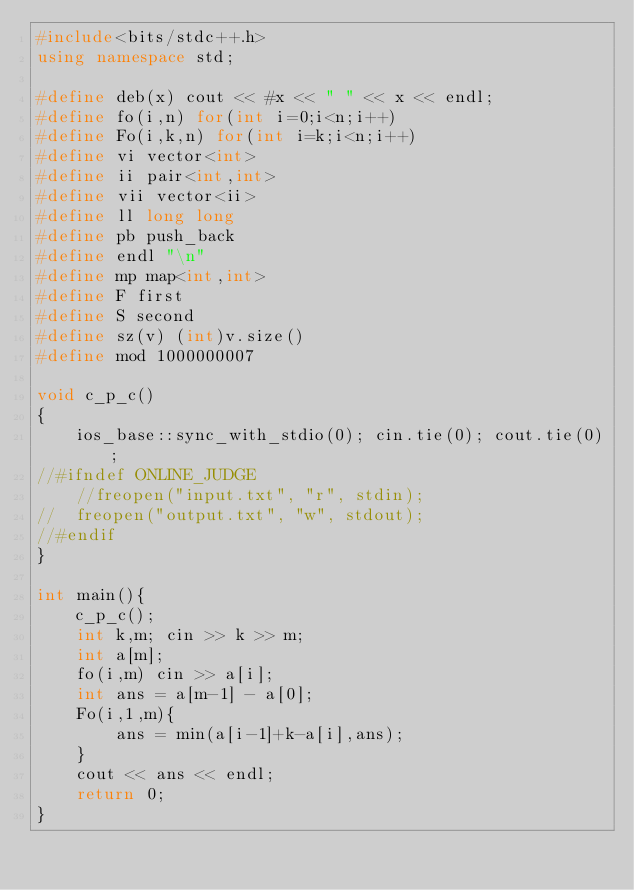<code> <loc_0><loc_0><loc_500><loc_500><_C++_>#include<bits/stdc++.h>
using namespace std;

#define deb(x) cout << #x << " " << x << endl;
#define fo(i,n) for(int i=0;i<n;i++)
#define Fo(i,k,n) for(int i=k;i<n;i++)
#define vi vector<int>
#define ii pair<int,int>
#define vii vector<ii>
#define ll long long
#define pb push_back
#define endl "\n"
#define mp map<int,int>
#define F first
#define S second
#define sz(v) (int)v.size()
#define mod 1000000007

void c_p_c()
{
	ios_base::sync_with_stdio(0); cin.tie(0); cout.tie(0);
//#ifndef ONLINE_JUDGE
	//freopen("input.txt", "r", stdin);
//	freopen("output.txt", "w", stdout);
//#endif
}

int main(){
	c_p_c();
	int k,m; cin >> k >> m;
	int a[m];
	fo(i,m) cin >> a[i];
	int ans = a[m-1] - a[0];
	Fo(i,1,m){
		ans = min(a[i-1]+k-a[i],ans);
	}
	cout << ans << endl;
	return 0;
}</code> 